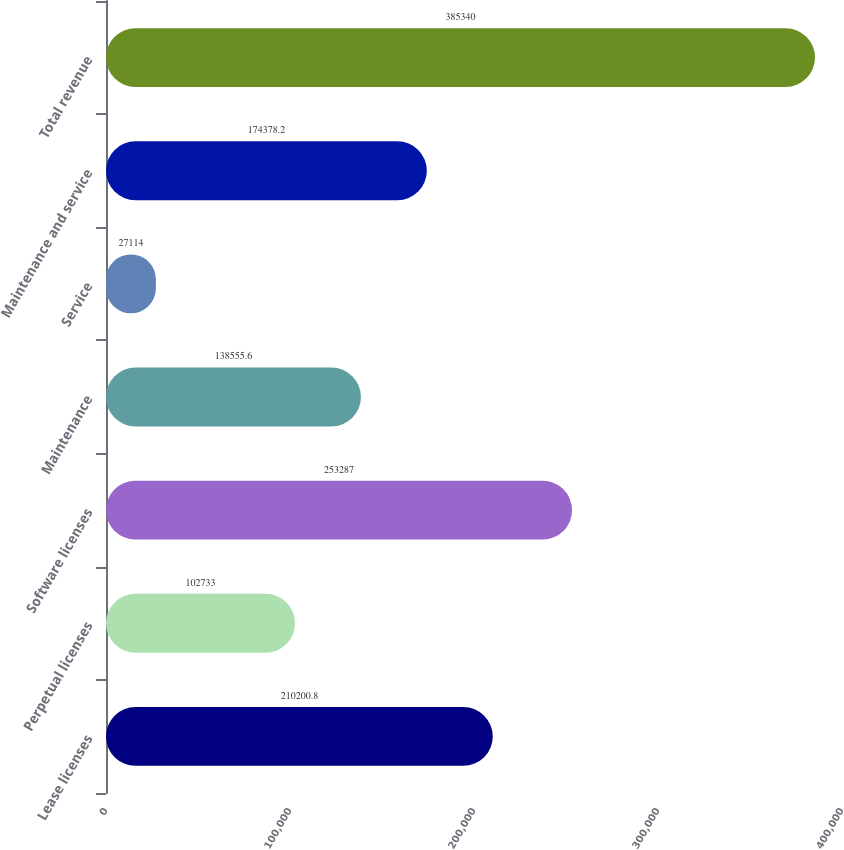<chart> <loc_0><loc_0><loc_500><loc_500><bar_chart><fcel>Lease licenses<fcel>Perpetual licenses<fcel>Software licenses<fcel>Maintenance<fcel>Service<fcel>Maintenance and service<fcel>Total revenue<nl><fcel>210201<fcel>102733<fcel>253287<fcel>138556<fcel>27114<fcel>174378<fcel>385340<nl></chart> 